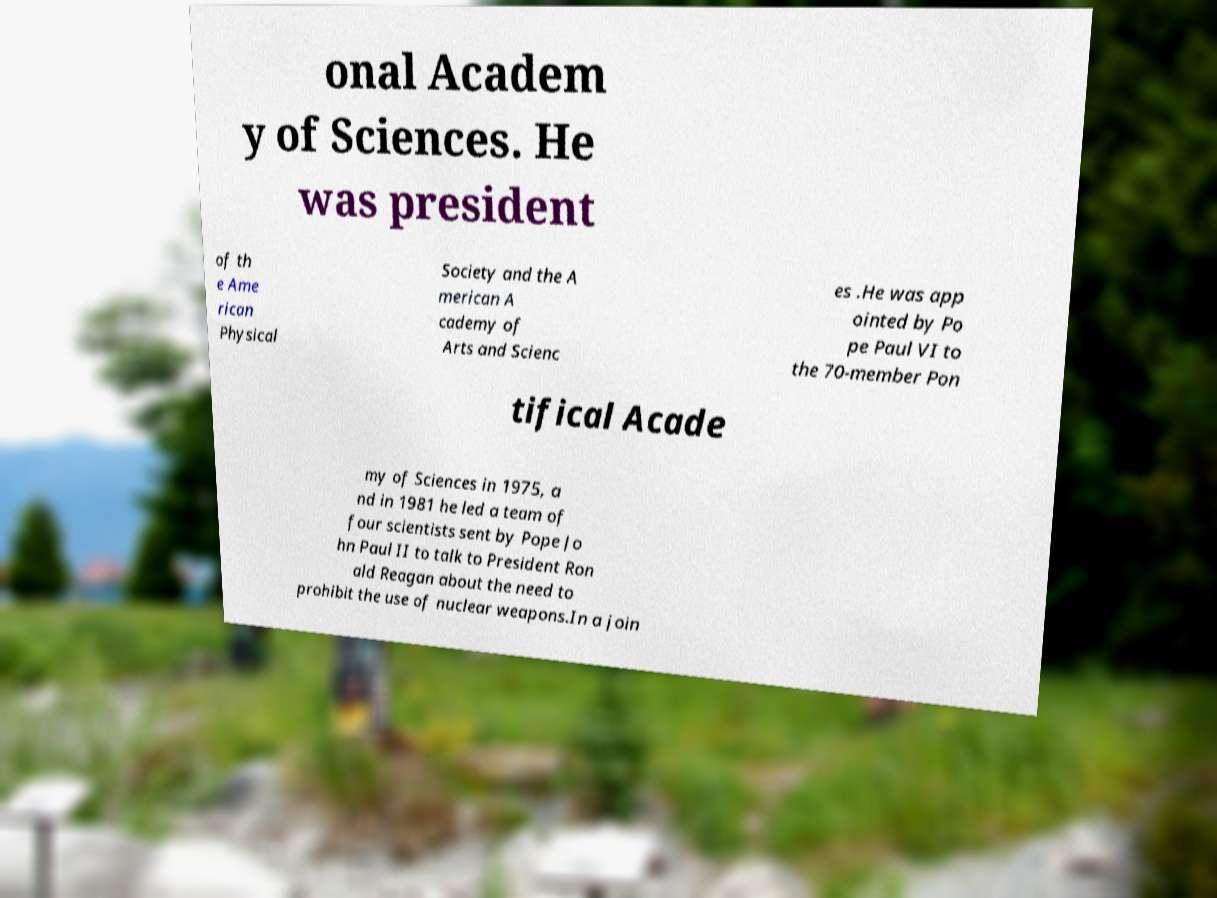I need the written content from this picture converted into text. Can you do that? onal Academ y of Sciences. He was president of th e Ame rican Physical Society and the A merican A cademy of Arts and Scienc es .He was app ointed by Po pe Paul VI to the 70-member Pon tifical Acade my of Sciences in 1975, a nd in 1981 he led a team of four scientists sent by Pope Jo hn Paul II to talk to President Ron ald Reagan about the need to prohibit the use of nuclear weapons.In a join 